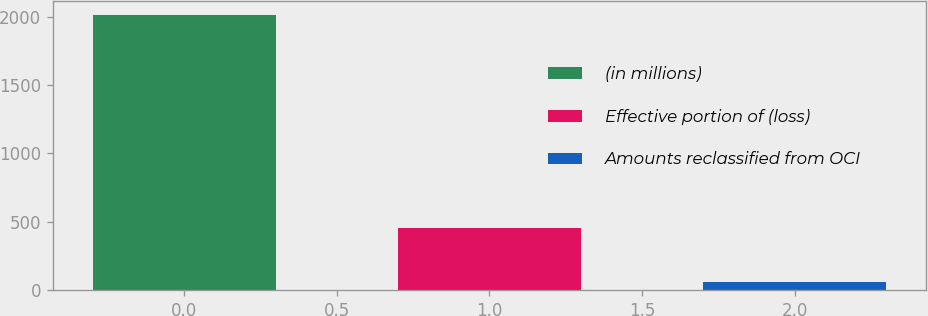<chart> <loc_0><loc_0><loc_500><loc_500><bar_chart><fcel>(in millions)<fcel>Effective portion of (loss)<fcel>Amounts reclassified from OCI<nl><fcel>2015<fcel>450.2<fcel>59<nl></chart> 